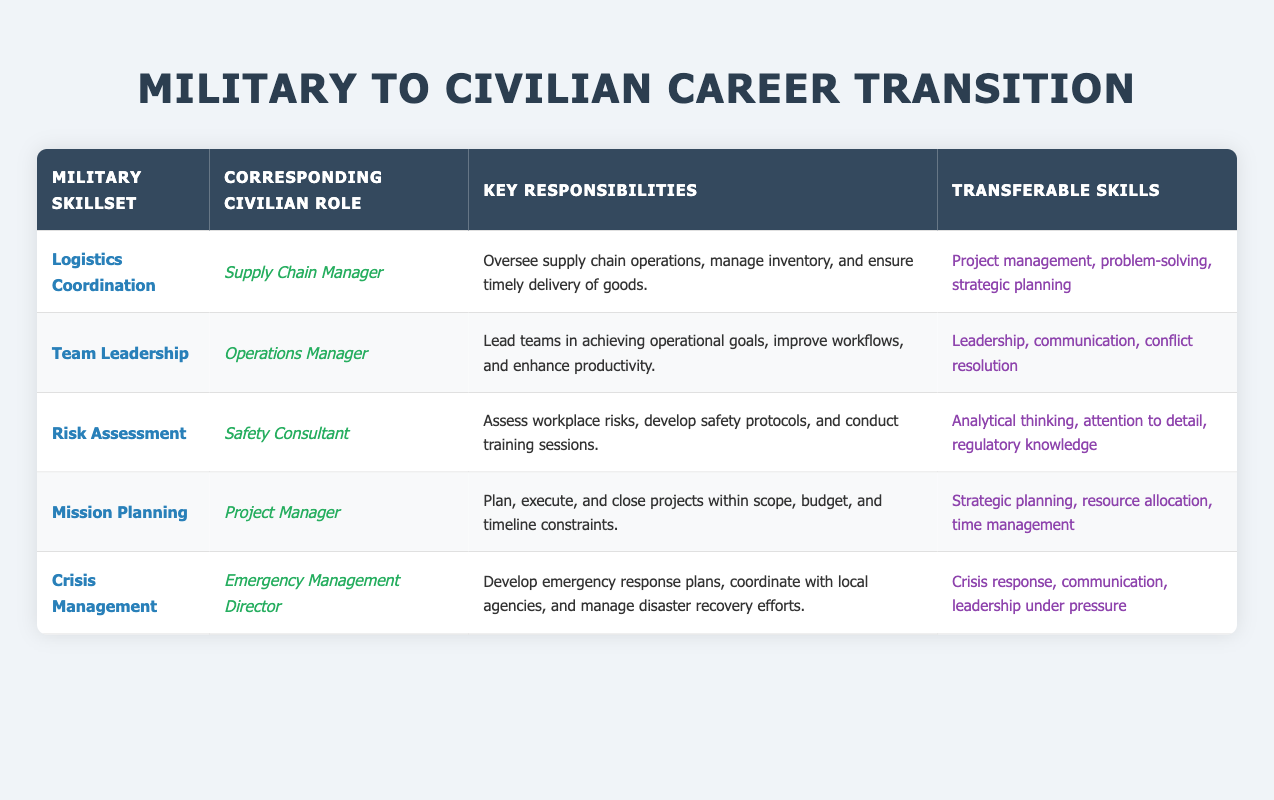What is the civilian role corresponding to "Logistics Coordination"? According to the table, the civilian role that corresponds to "Logistics Coordination" is "Supply Chain Manager."
Answer: Supply Chain Manager What transferable skills are associated with the role of "Project Manager"? The table indicates that the transferable skills related to the "Project Manager" role are "Strategic planning, resource allocation, time management."
Answer: Strategic planning, resource allocation, time management Is "Crisis Management" a military skillset that correlates with an emergency response role? Yes, the table confirms that "Crisis Management" is associated with the civilian role of "Emergency Management Director," which involves emergency response activities.
Answer: Yes What key responsibilities are listed for the "Safety Consultant" role? The table specifies that the key responsibilities for the "Safety Consultant" role include "Assess workplace risks, develop safety protocols, and conduct training sessions."
Answer: Assess workplace risks, develop safety protocols, and conduct training sessions Which civilian role involves leading teams and enhancing productivity? The "Operations Manager" role is identified in the table as one that involves leading teams in achieving operational goals and enhancing productivity.
Answer: Operations Manager How many military skillsets correspond to roles that involve crisis or emergency management? There are two military skillsets, "Crisis Management" and "Risk Assessment," that correspond to civilian roles involving emergency management or assessing risks to ensure safety.
Answer: 2 Does the role of "Supply Chain Manager" require analytical thinking skills? Yes, the transferable skills required for the "Supply Chain Manager" role include "Project management, problem-solving, strategic planning," where analytical thinking is applicable.
Answer: Yes Which military skillset has the highest number of transferable skills listed? "Logistics Coordination" has three transferable skills: "Project management, problem-solving, strategic planning," matching the highest number across the table.
Answer: Logistics Coordination What responsibilities are common to both "Project Manager" and "Emergency Management Director" roles based on the table? Both roles, "Project Manager" and "Emergency Management Director," have responsibilities that involve planning and executing specific tasks: "Project Manager" focuses on projects while "Emergency Management Director" develops response plans.
Answer: Planning and executing tasks 